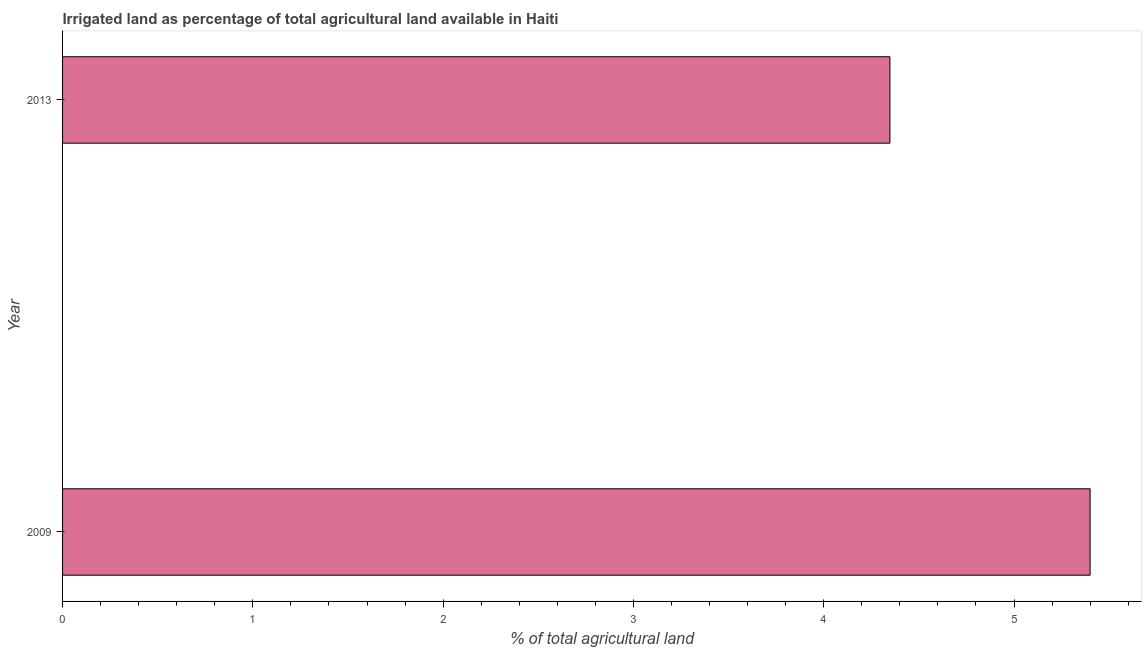Does the graph contain any zero values?
Your answer should be compact. No. What is the title of the graph?
Your response must be concise. Irrigated land as percentage of total agricultural land available in Haiti. What is the label or title of the X-axis?
Keep it short and to the point. % of total agricultural land. What is the percentage of agricultural irrigated land in 2009?
Give a very brief answer. 5.4. Across all years, what is the maximum percentage of agricultural irrigated land?
Provide a succinct answer. 5.4. Across all years, what is the minimum percentage of agricultural irrigated land?
Offer a very short reply. 4.35. What is the sum of the percentage of agricultural irrigated land?
Make the answer very short. 9.75. What is the difference between the percentage of agricultural irrigated land in 2009 and 2013?
Provide a short and direct response. 1.05. What is the average percentage of agricultural irrigated land per year?
Your response must be concise. 4.87. What is the median percentage of agricultural irrigated land?
Provide a succinct answer. 4.87. Do a majority of the years between 2009 and 2013 (inclusive) have percentage of agricultural irrigated land greater than 1.4 %?
Keep it short and to the point. Yes. What is the ratio of the percentage of agricultural irrigated land in 2009 to that in 2013?
Keep it short and to the point. 1.24. How many bars are there?
Offer a very short reply. 2. How many years are there in the graph?
Ensure brevity in your answer.  2. Are the values on the major ticks of X-axis written in scientific E-notation?
Your response must be concise. No. What is the % of total agricultural land in 2009?
Your answer should be compact. 5.4. What is the % of total agricultural land of 2013?
Offer a terse response. 4.35. What is the difference between the % of total agricultural land in 2009 and 2013?
Keep it short and to the point. 1.05. What is the ratio of the % of total agricultural land in 2009 to that in 2013?
Your response must be concise. 1.24. 